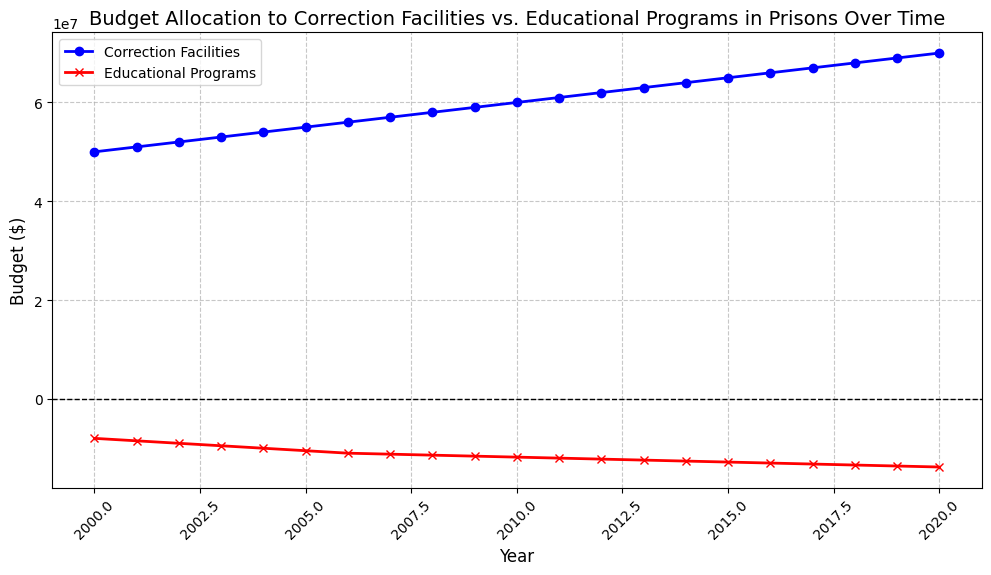What is the general trend for the budget allocated to correction facilities over time? Looking at the blue line representing the Correction Facilities budget, it shows an upward trend from 2000 to 2020. Each year, the budget increases consistently.
Answer: Upward trend What occurs to the budget allocated to educational programs between the years 2008 and 2012? Referring to the red line representing the Educational Programs budget, it shows a decrease from -11,400,000 in 2008 to -12,200,000 in 2012.
Answer: Decreases Which year has the highest budget allocation for correction facilities? By examining the peak of the blue line, 2020 stands out as the year with the highest budget allocation for correction facilities, at 70,000,000.
Answer: 2020 How do the budget allocations to correction facilities and educational programs in 2010 compare? In 2010, the budget for correction facilities is 60,000,000 (blue line), while the budget for educational programs is -11,800,000 (red line), indicating that much more budget is allocated to correction facilities compared to educational programs.
Answer: Correction facilities have a much higher budget than educational programs Is there any year where the budget for educational programs increased compared to the previous year? Upon examining the red line, there is no year where the budget for educational programs increases; it continuously decreases from 2000 to 2020.
Answer: No What is the difference in budget allocation to correction facilities from 2000 to 2010? The budget in 2000 for correction facilities is 50,000,000, and in 2010 it is 60,000,000. The difference is 60,000,000 - 50,000,000 = 10,000,000.
Answer: 10,000,000 In which year were both budgets the closest to each other in absolute value? By comparing the lines, in 2000, the correction facilities budget is 50,000,000 and the educational programs budget is -8,000,000, so their absolute difference is 58,000,000. This becomes the smallest difference when comparing other year pairs.
Answer: 2000 What is the average budget allocated to educational programs from 2000 to 2005? Sum the budgets: -8,000,000 + -8,500,000 + -9,000,000 + -9,500,000 + -10,000,000 + -10,500,000 = -55,500,000. Dividing by 6 years gives an average budget: -55,500,000 / 6 = -9,250,000.
Answer: -9,250,000 What visual difference stands out between the two budget lines? The blue line for correction facilities trends upward consistently, whereas the red line for educational programs trends downward consistently. The blue line is represented with circle markers, while the red line uses cross markers.
Answer: Upward vs. downward trends, circles vs. crosses How does the slope of the correction facilities budget line compare to the slope of the educational programs budget line? The slope of the blue line (correction facilities) is positive and consistent, indicating a steady increase year over year. The slope of the red line (educational programs) is negative and consistent, showing a steady decrease each year.
Answer: Positive vs. negative slopes 